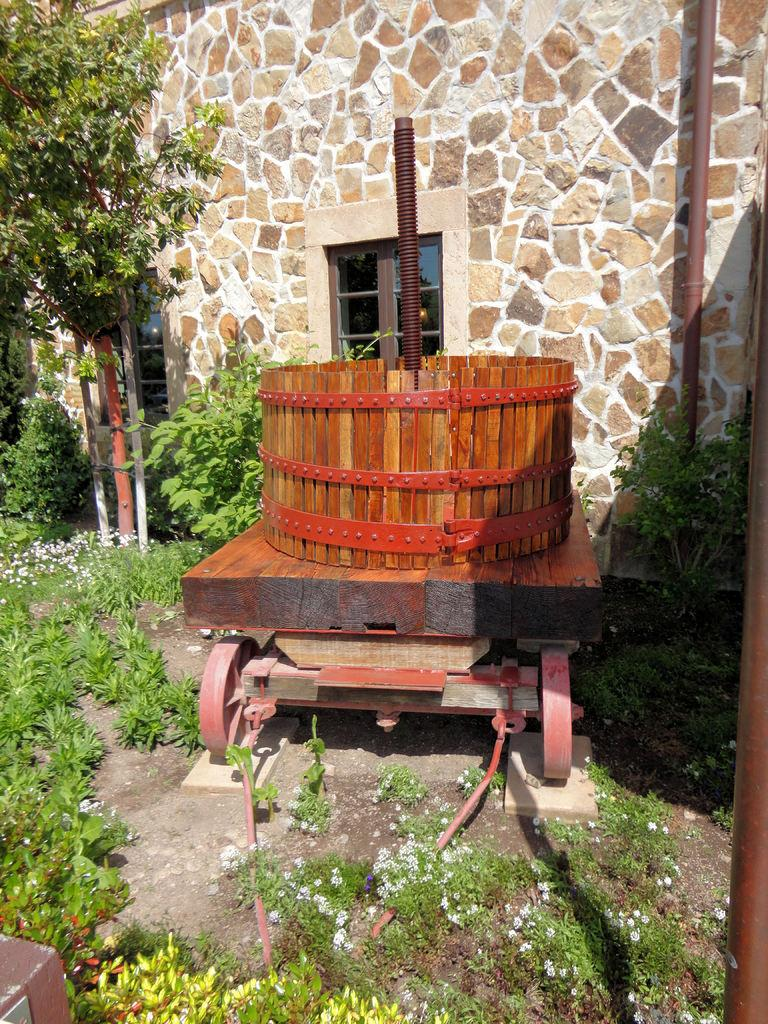What type of vegetation can be seen in the image? There is grass, plants, and flowers in the image. What else is present in the image besides vegetation? There is a vehicle and a wall with windows in the background of the image. Can you describe the wall in the background? The wall has windows in the background of the image. What type of marble is visible in the image? There is no marble present in the image. What nation is represented by the flag in the image? There is no flag present in the image. 